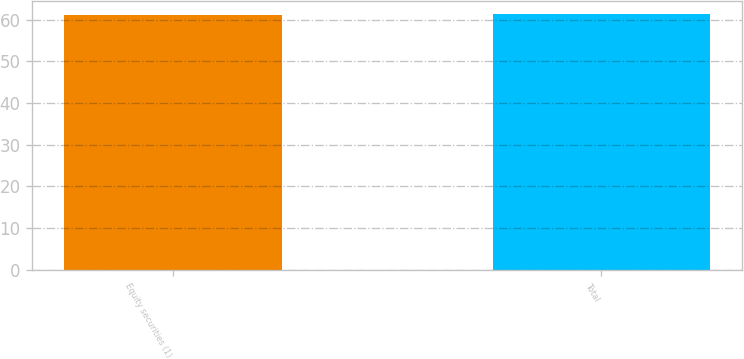Convert chart to OTSL. <chart><loc_0><loc_0><loc_500><loc_500><bar_chart><fcel>Equity securities (1)<fcel>Total<nl><fcel>61.2<fcel>61.3<nl></chart> 